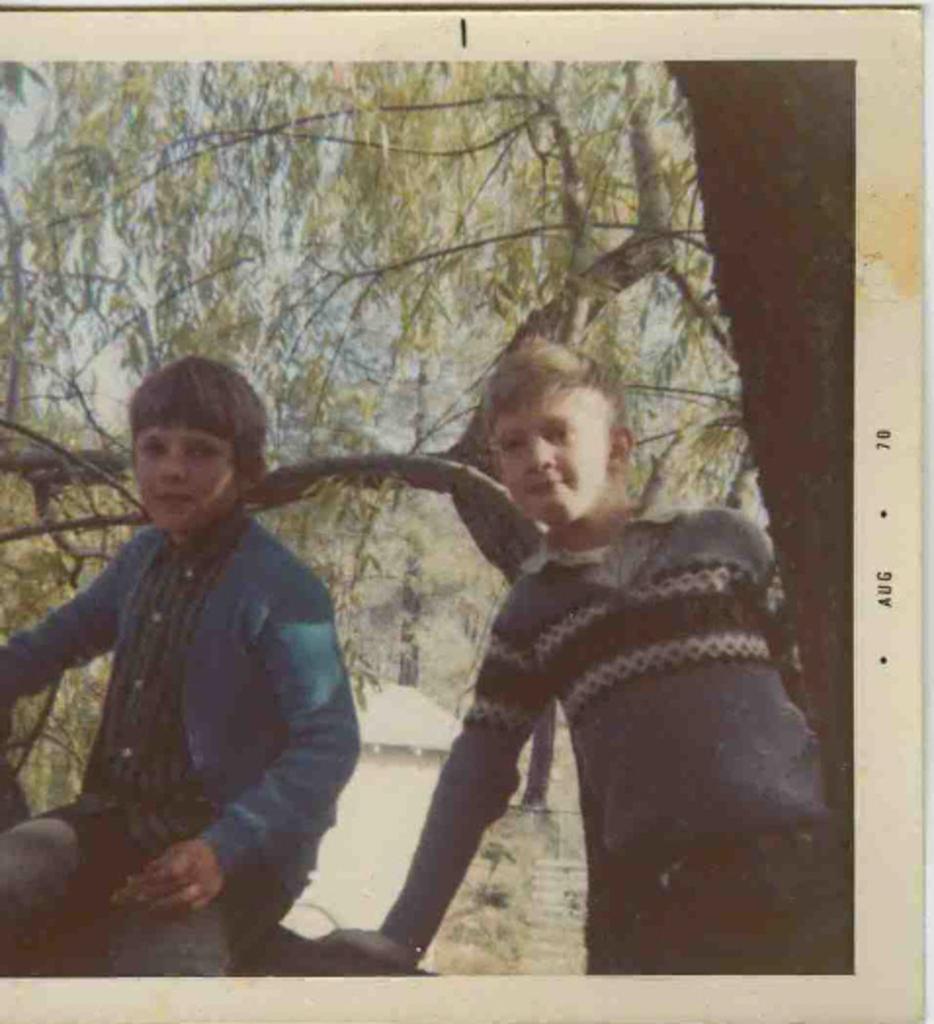In one or two sentences, can you explain what this image depicts? In this picture there is a boy with blue jacket is sitting and there is another boy and he might be sitting. At the back there are trees. At the top there is sky. On the right side of the image there is text. 